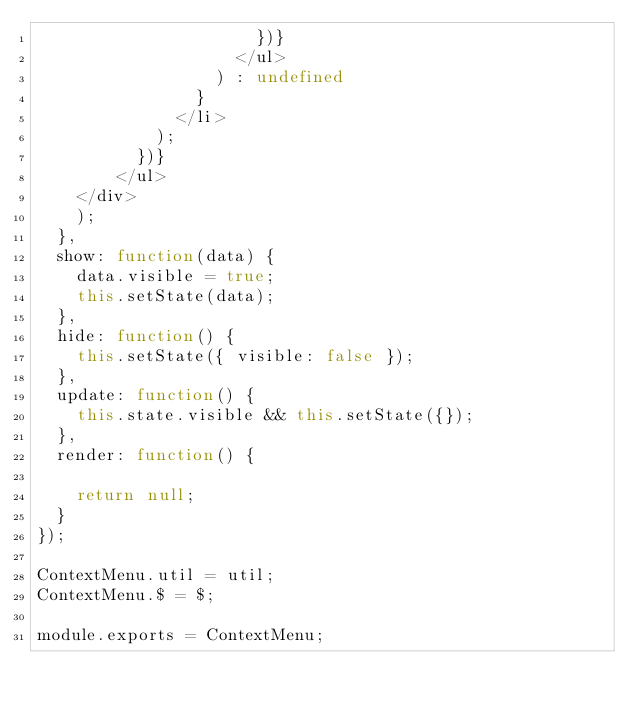Convert code to text. <code><loc_0><loc_0><loc_500><loc_500><_JavaScript_>                      })}
                    </ul>
                  ) : undefined
                }
              </li>
            );
          })}
        </ul>
    </div>
    );
  },
  show: function(data) {
    data.visible = true;
    this.setState(data);
  },
  hide: function() {
    this.setState({ visible: false });
  },
  update: function() {
    this.state.visible && this.setState({});
  },
  render: function() {

    return null;
  }
});

ContextMenu.util = util;
ContextMenu.$ = $;

module.exports = ContextMenu;
</code> 